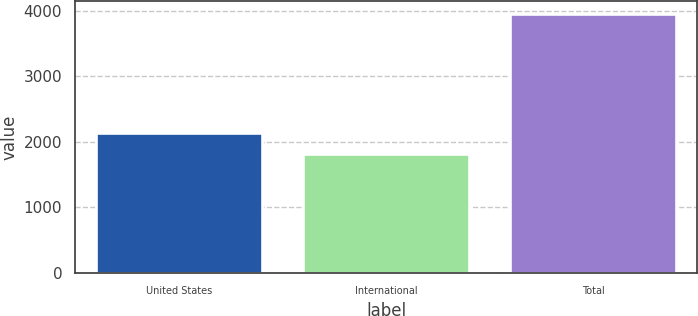Convert chart. <chart><loc_0><loc_0><loc_500><loc_500><bar_chart><fcel>United States<fcel>International<fcel>Total<nl><fcel>2130<fcel>1817<fcel>3947<nl></chart> 